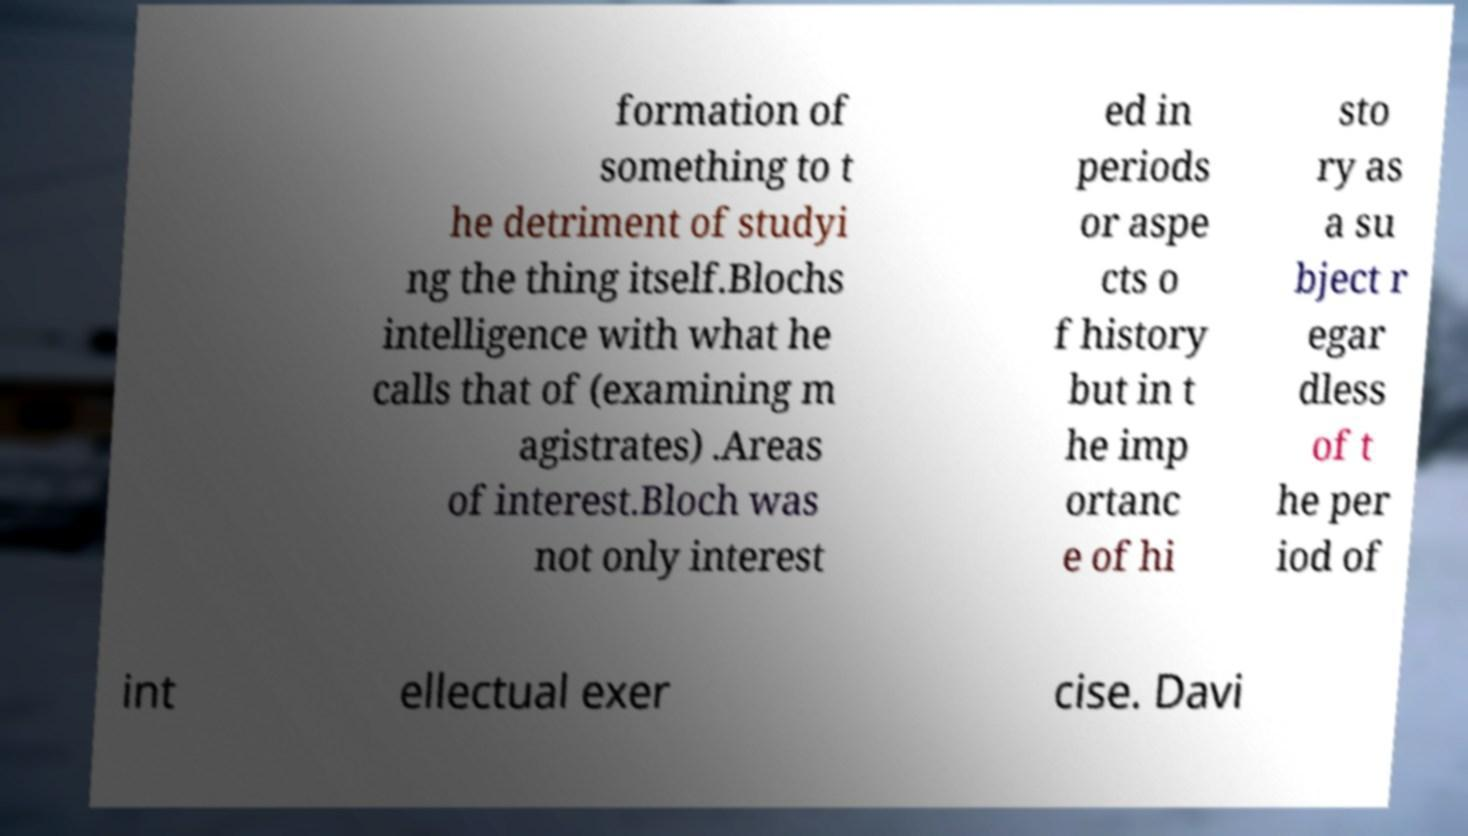Can you accurately transcribe the text from the provided image for me? formation of something to t he detriment of studyi ng the thing itself.Blochs intelligence with what he calls that of (examining m agistrates) .Areas of interest.Bloch was not only interest ed in periods or aspe cts o f history but in t he imp ortanc e of hi sto ry as a su bject r egar dless of t he per iod of int ellectual exer cise. Davi 